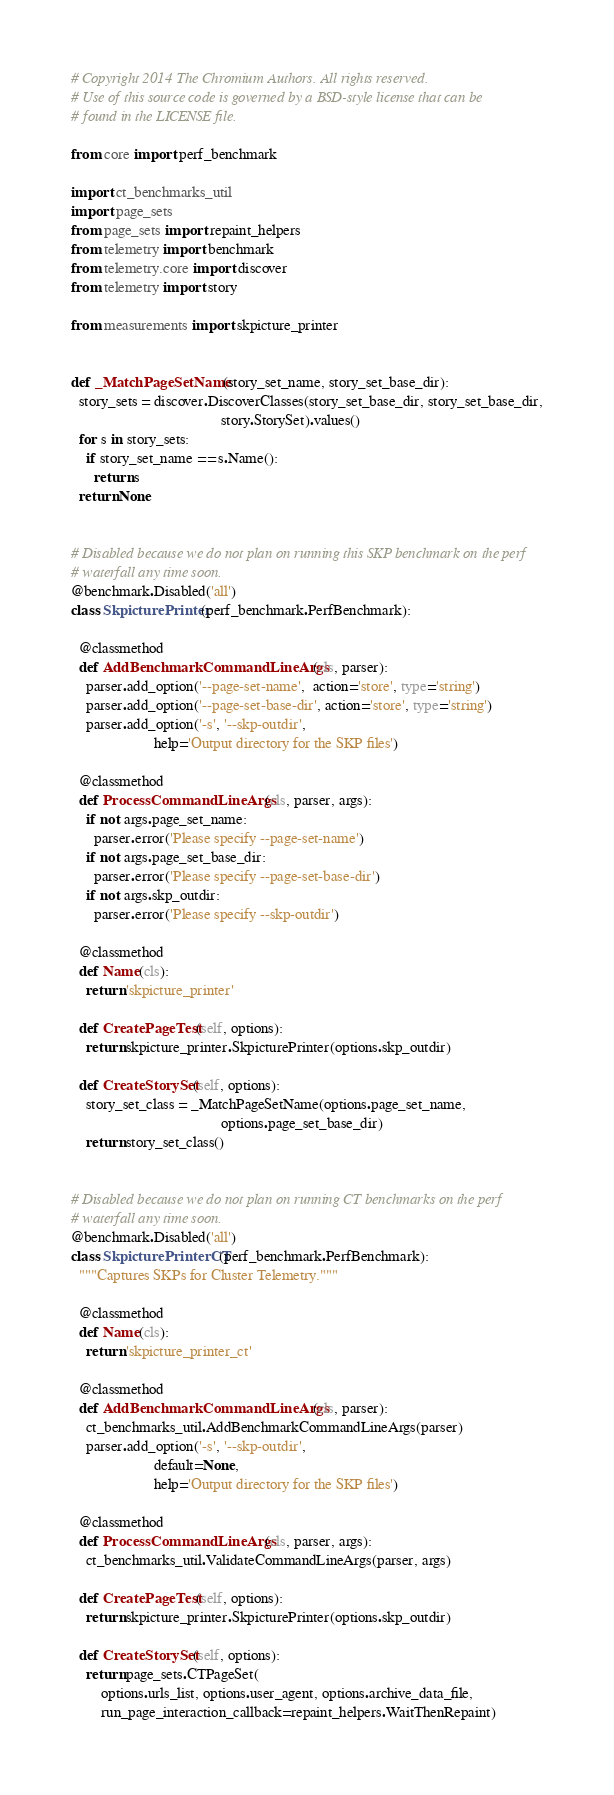<code> <loc_0><loc_0><loc_500><loc_500><_Python_># Copyright 2014 The Chromium Authors. All rights reserved.
# Use of this source code is governed by a BSD-style license that can be
# found in the LICENSE file.

from core import perf_benchmark

import ct_benchmarks_util
import page_sets
from page_sets import repaint_helpers
from telemetry import benchmark
from telemetry.core import discover
from telemetry import story

from measurements import skpicture_printer


def _MatchPageSetName(story_set_name, story_set_base_dir):
  story_sets = discover.DiscoverClasses(story_set_base_dir, story_set_base_dir,
                                        story.StorySet).values()
  for s in story_sets:
    if story_set_name == s.Name():
      return s
  return None


# Disabled because we do not plan on running this SKP benchmark on the perf
# waterfall any time soon.
@benchmark.Disabled('all')
class SkpicturePrinter(perf_benchmark.PerfBenchmark):

  @classmethod
  def AddBenchmarkCommandLineArgs(cls, parser):
    parser.add_option('--page-set-name',  action='store', type='string')
    parser.add_option('--page-set-base-dir', action='store', type='string')
    parser.add_option('-s', '--skp-outdir',
                      help='Output directory for the SKP files')

  @classmethod
  def ProcessCommandLineArgs(cls, parser, args):
    if not args.page_set_name:
      parser.error('Please specify --page-set-name')
    if not args.page_set_base_dir:
      parser.error('Please specify --page-set-base-dir')
    if not args.skp_outdir:
      parser.error('Please specify --skp-outdir')

  @classmethod
  def Name(cls):
    return 'skpicture_printer'

  def CreatePageTest(self, options):
    return skpicture_printer.SkpicturePrinter(options.skp_outdir)

  def CreateStorySet(self, options):
    story_set_class = _MatchPageSetName(options.page_set_name,
                                        options.page_set_base_dir)
    return story_set_class()


# Disabled because we do not plan on running CT benchmarks on the perf
# waterfall any time soon.
@benchmark.Disabled('all')
class SkpicturePrinterCT(perf_benchmark.PerfBenchmark):
  """Captures SKPs for Cluster Telemetry."""

  @classmethod
  def Name(cls):
    return 'skpicture_printer_ct'

  @classmethod
  def AddBenchmarkCommandLineArgs(cls, parser):
    ct_benchmarks_util.AddBenchmarkCommandLineArgs(parser)
    parser.add_option('-s', '--skp-outdir',
                      default=None,
                      help='Output directory for the SKP files')

  @classmethod
  def ProcessCommandLineArgs(cls, parser, args):
    ct_benchmarks_util.ValidateCommandLineArgs(parser, args)

  def CreatePageTest(self, options):
    return skpicture_printer.SkpicturePrinter(options.skp_outdir)

  def CreateStorySet(self, options):
    return page_sets.CTPageSet(
        options.urls_list, options.user_agent, options.archive_data_file,
        run_page_interaction_callback=repaint_helpers.WaitThenRepaint)
</code> 